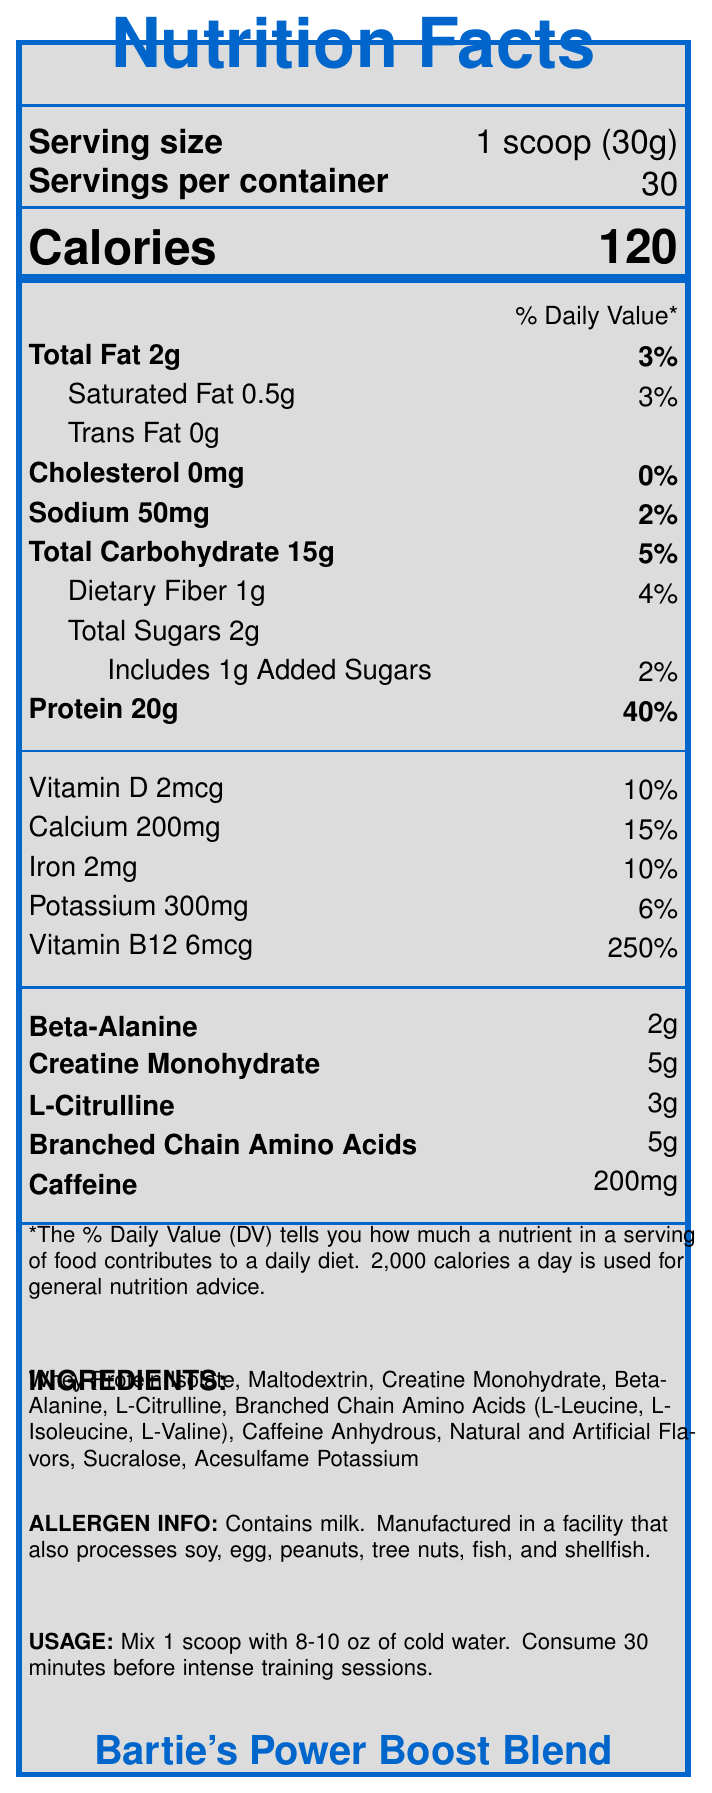how many servings are in the container? The document states "Servings per container: 30."
Answer: 30 how many grams of protein are in one serving? The document lists "Protein 20g" for one serving.
Answer: 20g what percentage of the daily value of vitamin B12 does one serving provide? The document lists "Vitamin B12 6mcg (250%)" under % Daily Value.
Answer: 250% does the product contain any allergens? The document states, "Contains milk. Manufactured in a facility that also processes soy, egg, peanuts, tree nuts, fish, and shellfish."
Answer: Yes how should this supplement be consumed for best results? This is listed under "Usage Instructions" in the document.
Answer: Mix 1 scoop with 8-10 oz of cold water, 30 minutes before intense training sessions which nutrient has the highest % Daily Value per serving? A. Vitamin D B. Vitamin B12 C. Calcium D. Iron The document shows Vitamin B12 at 250% Daily Value, which is higher than any other listed nutrient.
Answer: B. Vitamin B12 how many grams of creatine monohydrate are in one serving? The document lists "Creatine Monohydrate 5g."
Answer: 5g does each serving contain more than 150 calories? The document lists "Calories: 120."
Answer: No is cholesterol present in the supplement blend? The document lists "Cholesterol 0mg."
Answer: No summarize the contents and purpose of this supplement blend. This summary covers the main components, purpose, and additional details about the nutritional contents and usage instructions written in the document.
Answer: "Bartie's Power Boost Blend" is a nutritional supplement designed to support intense training sessions. It has 30 servings per container, with each serving providing 120 calories, 20g of protein, and a significant boost in essential nutrients. It contains unique performance-enhancing ingredients like creatine monohydrate, beta-alanine, and caffeine, and includes dietary information and allergens. how much vitamin D is in the supplement? The document lists "Vitamin D 2mcg."
Answer: 2mcg explain why Alvin Bartie would add extra creatine to the blend. The document notes that Alvin always added extra creatine, but it does not explain why he did this.
Answer: Unknown which of the following is not an ingredient in the supplement? A. Whey Protein Isolate B. Beta-Alanine C. Sucralose D. Aspartame The ingredients list includes Whey Protein Isolate, Beta-Alanine, Sucralose, but not Aspartame.
Answer: D. Aspartame 